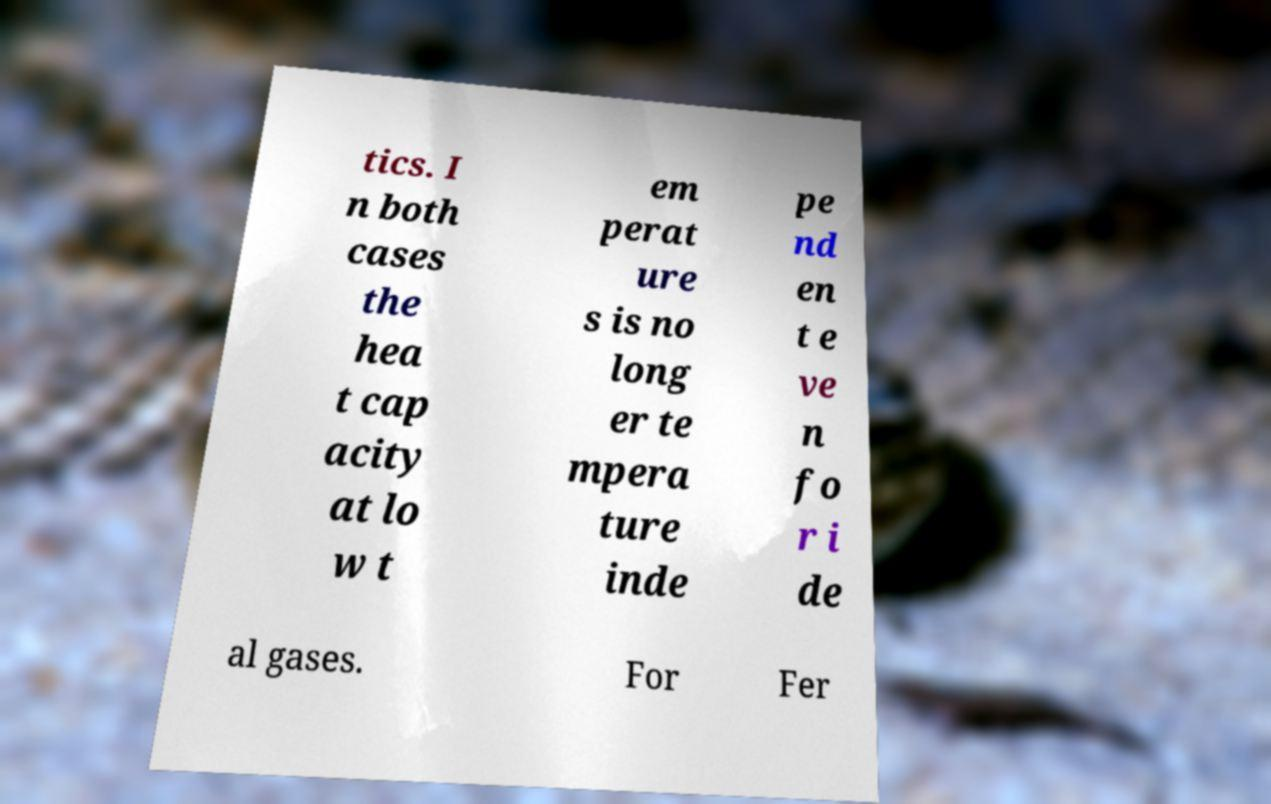Could you extract and type out the text from this image? tics. I n both cases the hea t cap acity at lo w t em perat ure s is no long er te mpera ture inde pe nd en t e ve n fo r i de al gases. For Fer 